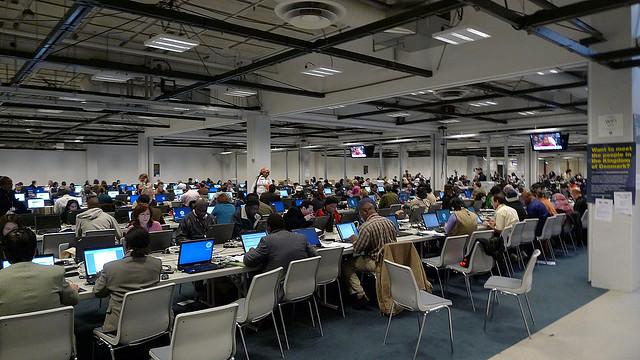How many chairs are not being utilized?
Be succinct. 6. How many computers are there?
Be succinct. 100. Do the televisions have the same image?
Keep it brief. Yes. Does it look like everyone is using a laptop?
Keep it brief. Yes. Is this a classroom?
Keep it brief. No. 